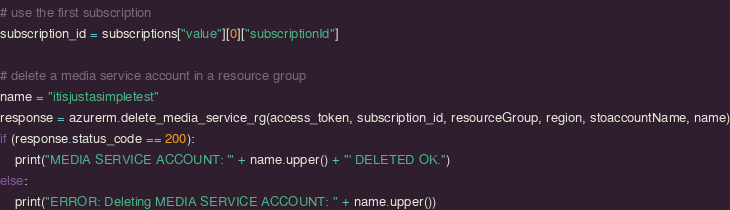Convert code to text. <code><loc_0><loc_0><loc_500><loc_500><_Python_># use the first subscription
subscription_id = subscriptions["value"][0]["subscriptionId"]

# delete a media service account in a resource group
name = "itisjustasimpletest"
response = azurerm.delete_media_service_rg(access_token, subscription_id, resourceGroup, region, stoaccountName, name)
if (response.status_code == 200):
	print("MEDIA SERVICE ACCOUNT: '" + name.upper() + "' DELETED OK.")
else:
	print("ERROR: Deleting MEDIA SERVICE ACCOUNT: " + name.upper())
</code> 